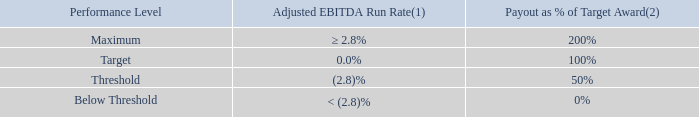2019 Performance Target and Payout: The ultimate number of our PBRS that vest, can range between 0% to 200%, and will be based on our achievement of the absolute Adjusted EBITDA Run Rate target (measured from fourth quarter of 2018 to fourth quarter of 2020), as illustrated in the table below.
(1) Determined by dividing (i) the Adjusted EBITDA actually attained for the fourth quarter of 2020 minus the Adjusted EBITDA actually attained for the fourth quarter of 2018 by (ii) the Adjusted EBITDA actually attained for the fourth quarter of 2018.
(2) Linear interpolation is used when our Adjusted EBITDA Run Rate performance is between the threshold, target and maximum amounts to determine the corresponding percentage of target award earned.
How is the Adjusted EBITDA Run Rate determined? Determined by dividing (i) the adjusted ebitda actually attained for the fourth quarter of 2020 minus the adjusted ebitda actually attained for the fourth quarter of 2018 by (ii) the adjusted ebitda actually attained for the fourth quarter of 2018. When determining the payout as a % of the target award, when is linear interpolation used? When our adjusted ebitda run rate performance is between the threshold, target and maximum amounts. What are the different performance levels? Maximum, target, threshold, below threshold. How many different performance levels are there? Maximum##Target##Threshold##Below Threshold
Answer: 4. How many performance levels would the payout as % of target award be above 50%? Maximum##Target
Answer: 2. What is the difference in the ratios of the payout expressed as % of Target Award for Maximum over Target compared against Target over Threshold? (200%/100%)-(100%/50%)
Answer: 0. 